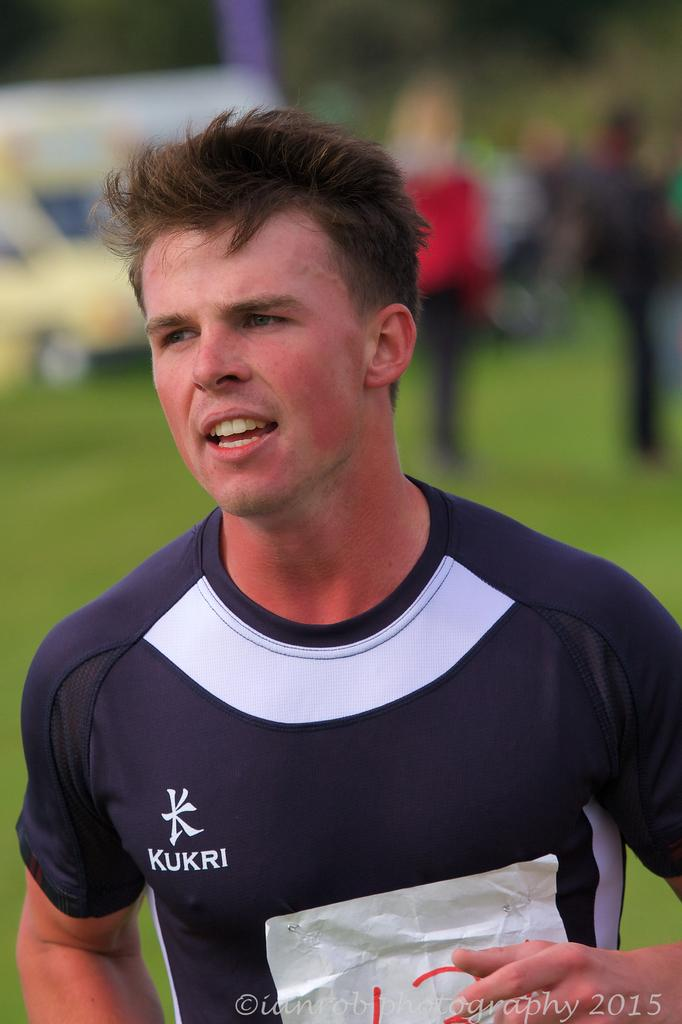Provide a one-sentence caption for the provided image. a an wearing a KUKRI shirt outside & copyrighted ianrobphotography 2015. 